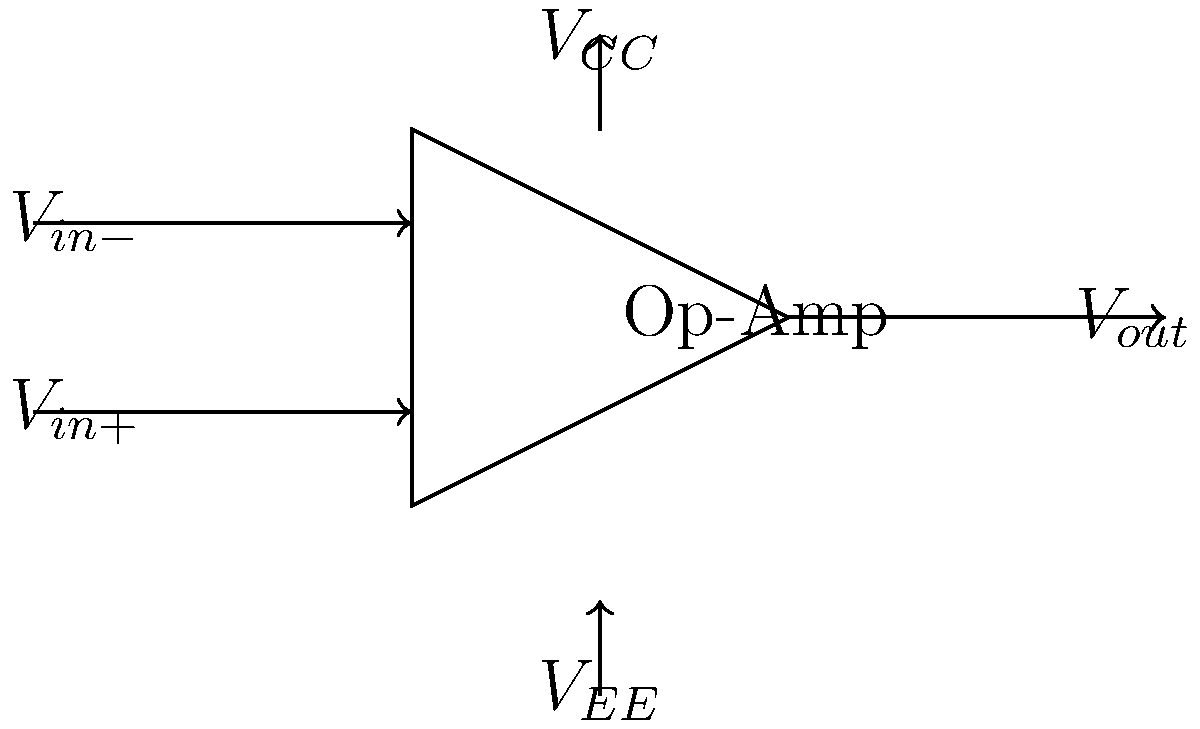In the context of women's contributions to electronic media, consider the basic operational amplifier circuit shown. How does the signal flow through this circuit, and what is the primary function of the op-amp in signal processing for audio or video applications? To understand the signal flow in this basic operational amplifier circuit:

1. Input stage: 
   - The circuit has two inputs: $V_{in+}$ (non-inverting) and $V_{in-}$ (inverting).
   - These inputs represent the differential input signal.

2. Amplification stage:
   - The op-amp amplifies the difference between $V_{in+}$ and $V_{in-}$.
   - The gain is typically very high in an ideal op-amp.

3. Output stage:
   - The amplified signal appears at $V_{out}$.
   - The output attempts to drive the difference between inputs to zero.

4. Power supply:
   - $V_{CC}$ and $V_{EE}$ provide power to the op-amp.
   - These determine the maximum output swing.

5. Function in signal processing:
   - Op-amps are used for various functions in audio/video applications:
     a) Amplification: Boosting weak signals
     b) Buffering: Isolating stages and impedance matching
     c) Filtering: Removing unwanted frequencies
     d) Summing: Combining multiple signals

6. Historical context:
   - Women like Erna Schneider Hoover contributed significantly to electronic switching systems, which utilize operational amplifiers.
   - The development of op-amps in integrated circuits revolutionized signal processing in media applications.

In essence, the op-amp takes a differential input, amplifies it, and produces a single-ended output, forming the basis for many signal processing functions in media technology.
Answer: The signal flows from differential inputs to a single amplified output, enabling various signal processing functions in audio/video applications. 